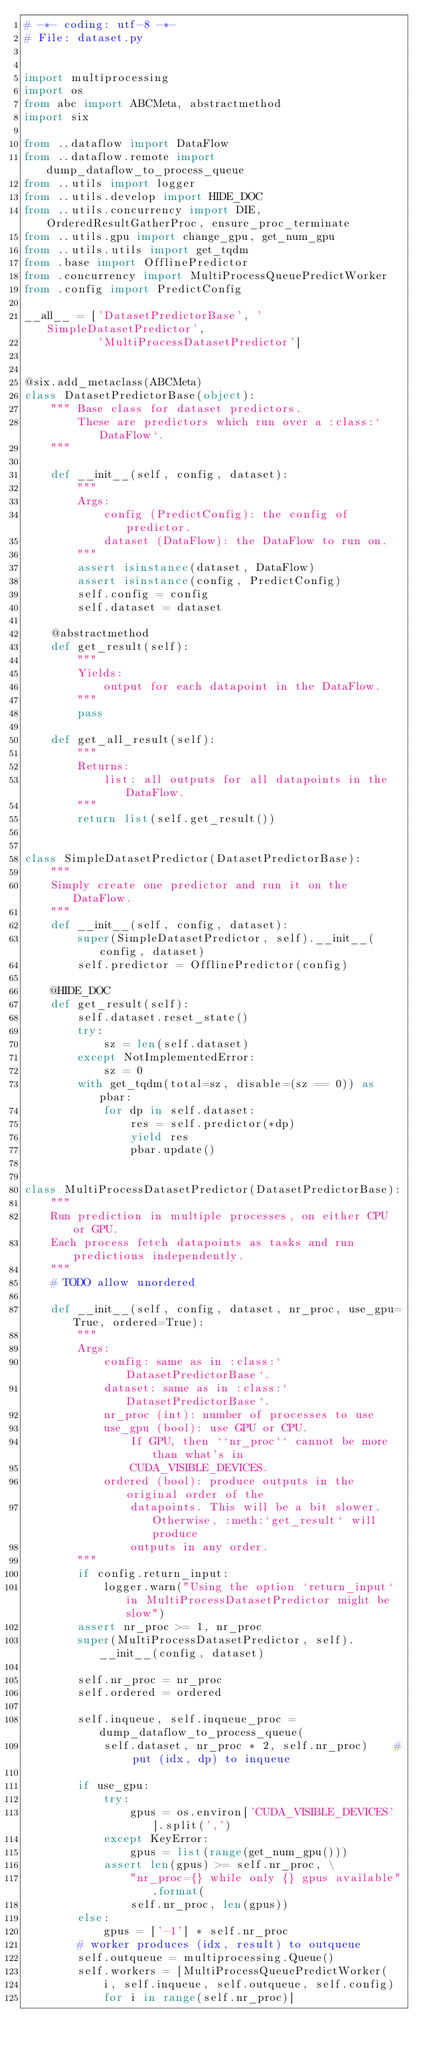Convert code to text. <code><loc_0><loc_0><loc_500><loc_500><_Python_># -*- coding: utf-8 -*-
# File: dataset.py


import multiprocessing
import os
from abc import ABCMeta, abstractmethod
import six

from ..dataflow import DataFlow
from ..dataflow.remote import dump_dataflow_to_process_queue
from ..utils import logger
from ..utils.develop import HIDE_DOC
from ..utils.concurrency import DIE, OrderedResultGatherProc, ensure_proc_terminate
from ..utils.gpu import change_gpu, get_num_gpu
from ..utils.utils import get_tqdm
from .base import OfflinePredictor
from .concurrency import MultiProcessQueuePredictWorker
from .config import PredictConfig

__all__ = ['DatasetPredictorBase', 'SimpleDatasetPredictor',
           'MultiProcessDatasetPredictor']


@six.add_metaclass(ABCMeta)
class DatasetPredictorBase(object):
    """ Base class for dataset predictors.
        These are predictors which run over a :class:`DataFlow`.
    """

    def __init__(self, config, dataset):
        """
        Args:
            config (PredictConfig): the config of predictor.
            dataset (DataFlow): the DataFlow to run on.
        """
        assert isinstance(dataset, DataFlow)
        assert isinstance(config, PredictConfig)
        self.config = config
        self.dataset = dataset

    @abstractmethod
    def get_result(self):
        """
        Yields:
            output for each datapoint in the DataFlow.
        """
        pass

    def get_all_result(self):
        """
        Returns:
            list: all outputs for all datapoints in the DataFlow.
        """
        return list(self.get_result())


class SimpleDatasetPredictor(DatasetPredictorBase):
    """
    Simply create one predictor and run it on the DataFlow.
    """
    def __init__(self, config, dataset):
        super(SimpleDatasetPredictor, self).__init__(config, dataset)
        self.predictor = OfflinePredictor(config)

    @HIDE_DOC
    def get_result(self):
        self.dataset.reset_state()
        try:
            sz = len(self.dataset)
        except NotImplementedError:
            sz = 0
        with get_tqdm(total=sz, disable=(sz == 0)) as pbar:
            for dp in self.dataset:
                res = self.predictor(*dp)
                yield res
                pbar.update()


class MultiProcessDatasetPredictor(DatasetPredictorBase):
    """
    Run prediction in multiple processes, on either CPU or GPU.
    Each process fetch datapoints as tasks and run predictions independently.
    """
    # TODO allow unordered

    def __init__(self, config, dataset, nr_proc, use_gpu=True, ordered=True):
        """
        Args:
            config: same as in :class:`DatasetPredictorBase`.
            dataset: same as in :class:`DatasetPredictorBase`.
            nr_proc (int): number of processes to use
            use_gpu (bool): use GPU or CPU.
                If GPU, then ``nr_proc`` cannot be more than what's in
                CUDA_VISIBLE_DEVICES.
            ordered (bool): produce outputs in the original order of the
                datapoints. This will be a bit slower. Otherwise, :meth:`get_result` will produce
                outputs in any order.
        """
        if config.return_input:
            logger.warn("Using the option `return_input` in MultiProcessDatasetPredictor might be slow")
        assert nr_proc >= 1, nr_proc
        super(MultiProcessDatasetPredictor, self).__init__(config, dataset)

        self.nr_proc = nr_proc
        self.ordered = ordered

        self.inqueue, self.inqueue_proc = dump_dataflow_to_process_queue(
            self.dataset, nr_proc * 2, self.nr_proc)    # put (idx, dp) to inqueue

        if use_gpu:
            try:
                gpus = os.environ['CUDA_VISIBLE_DEVICES'].split(',')
            except KeyError:
                gpus = list(range(get_num_gpu()))
            assert len(gpus) >= self.nr_proc, \
                "nr_proc={} while only {} gpus available".format(
                self.nr_proc, len(gpus))
        else:
            gpus = ['-1'] * self.nr_proc
        # worker produces (idx, result) to outqueue
        self.outqueue = multiprocessing.Queue()
        self.workers = [MultiProcessQueuePredictWorker(
            i, self.inqueue, self.outqueue, self.config)
            for i in range(self.nr_proc)]
</code> 